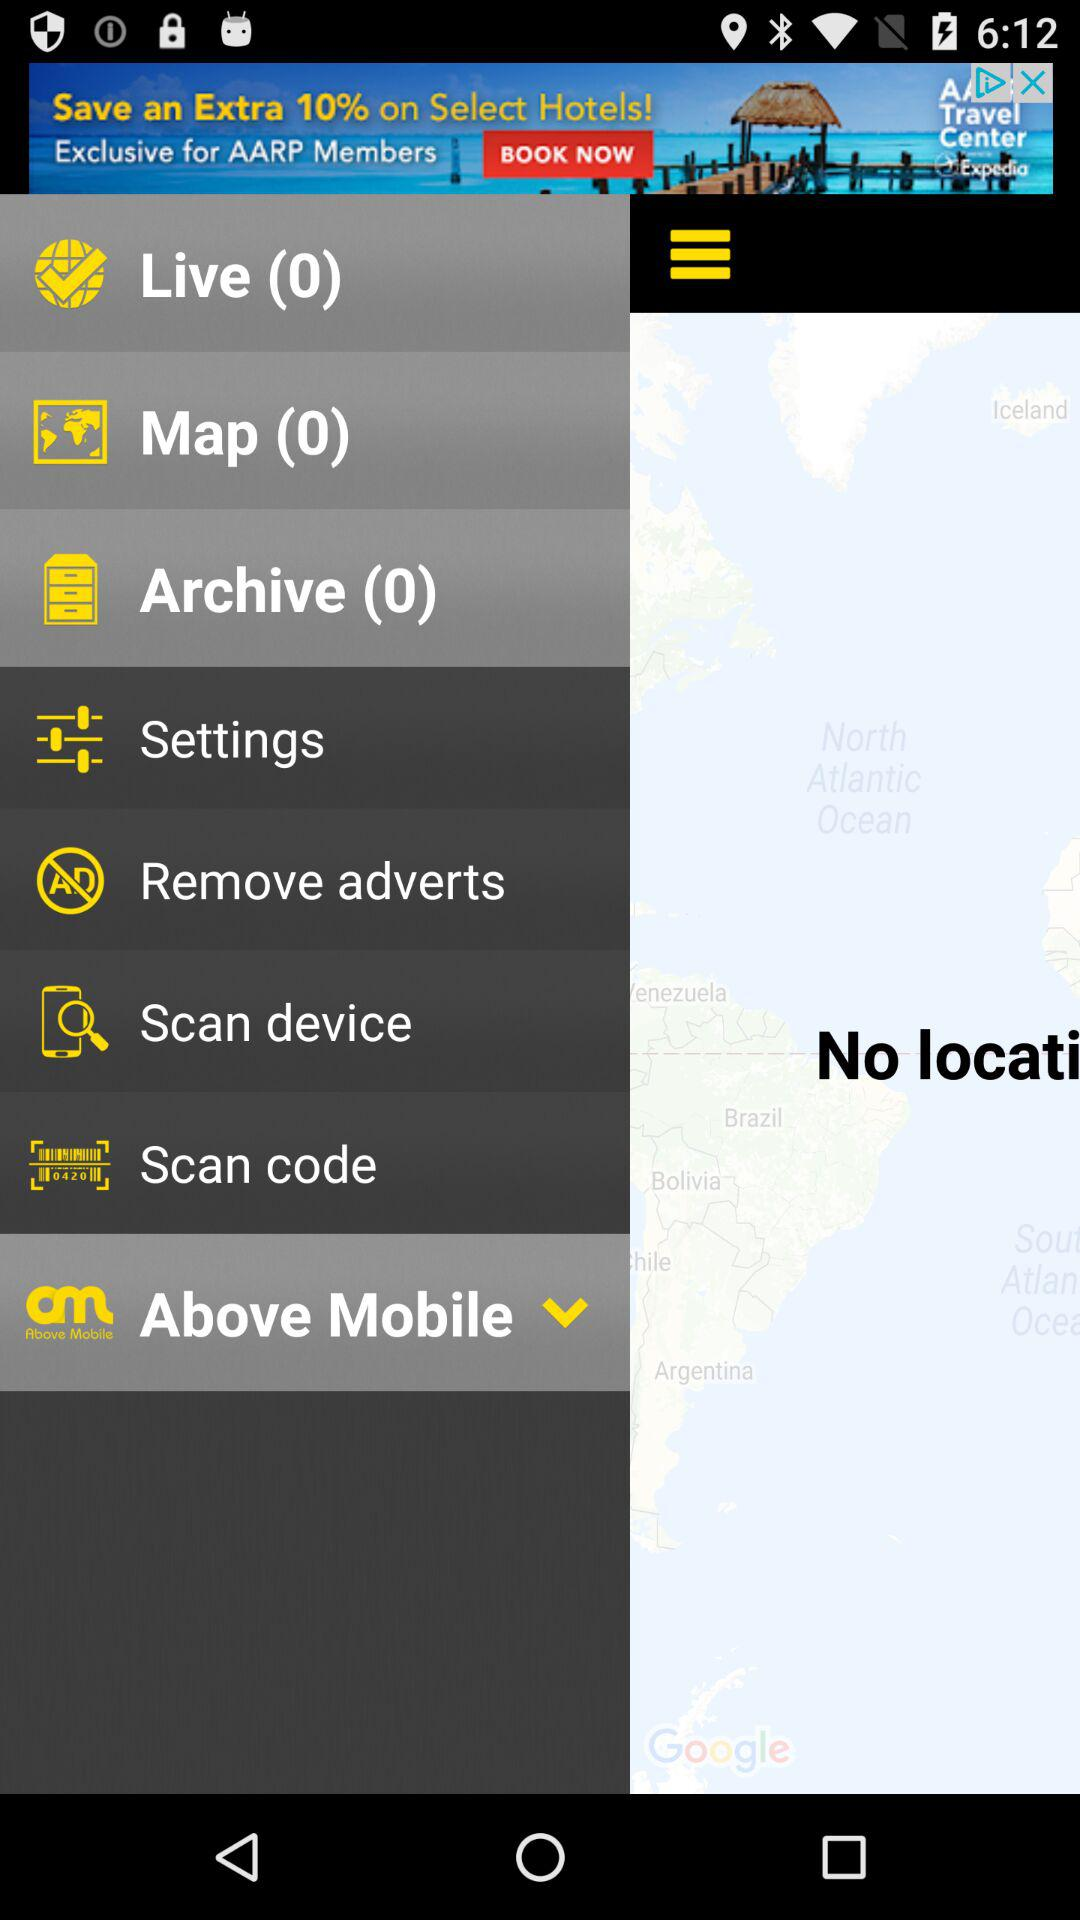What is the number of items in "Live"? The number of items in "Live" is 0. 